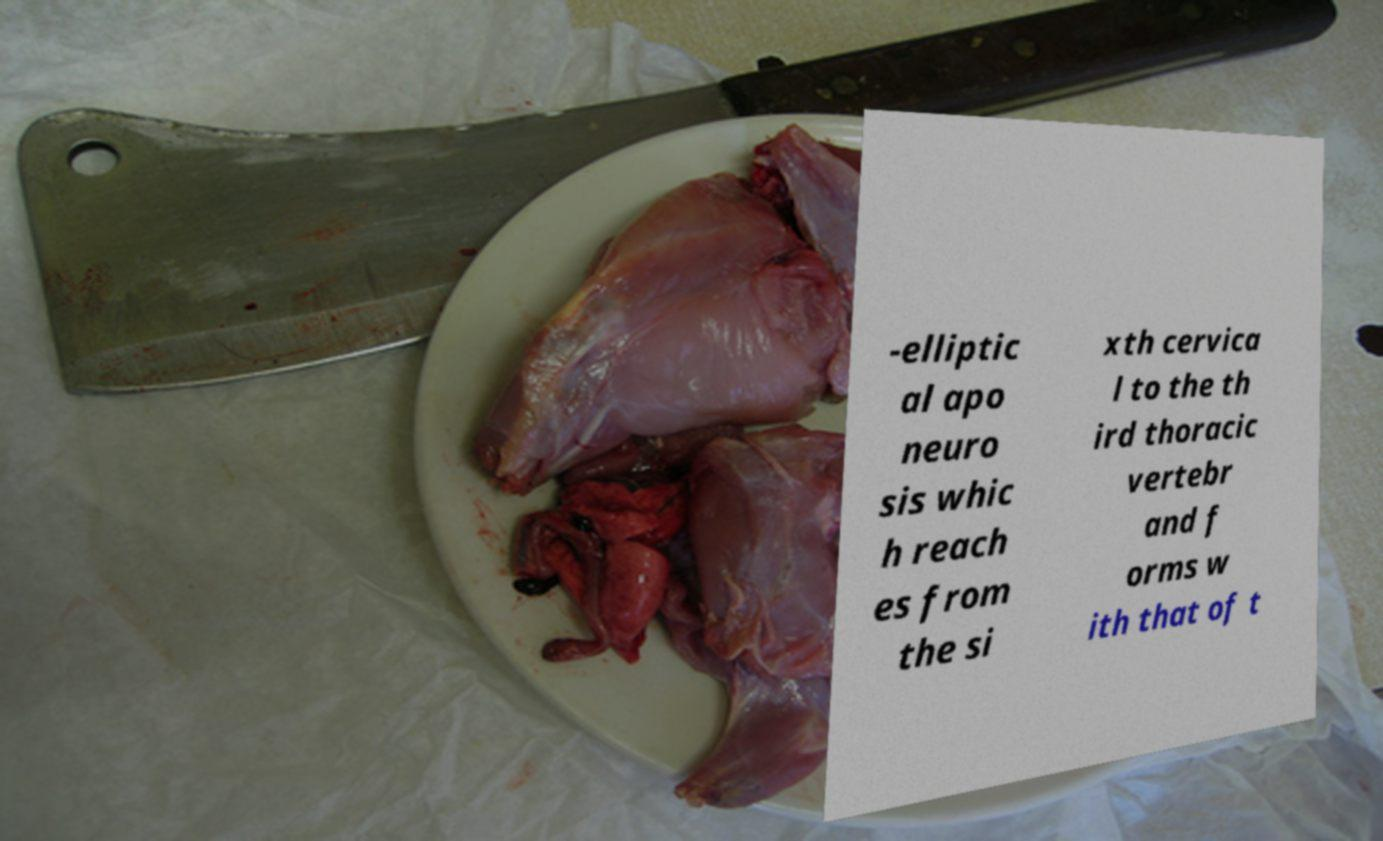Can you accurately transcribe the text from the provided image for me? -elliptic al apo neuro sis whic h reach es from the si xth cervica l to the th ird thoracic vertebr and f orms w ith that of t 